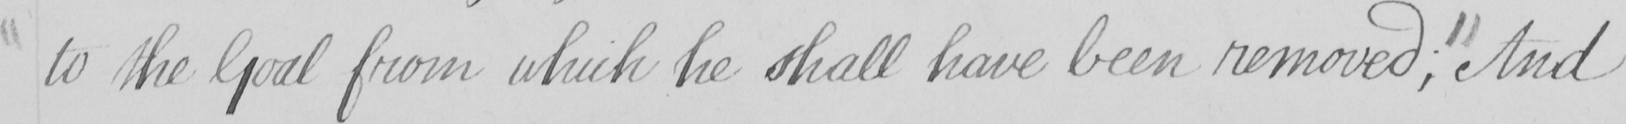Transcribe the text shown in this historical manuscript line. to the Goal from which he shall have been removed ;  "  And 